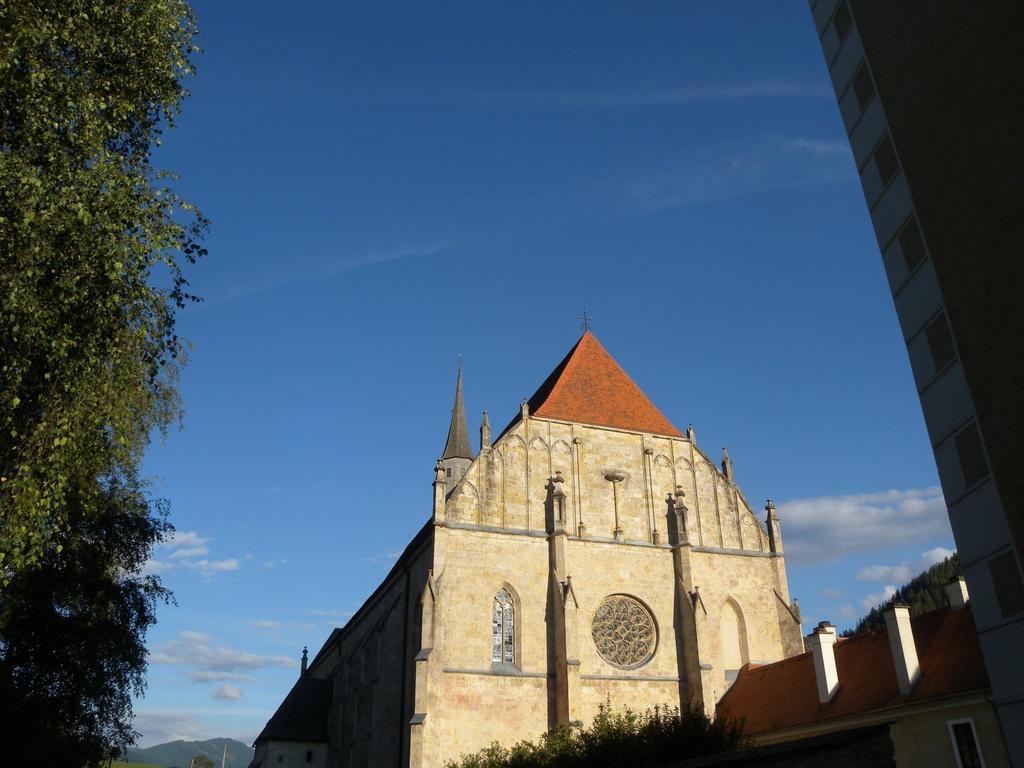Can you describe this image briefly? In the image we can see there are buildings and trees. There is clear sky on the top. 